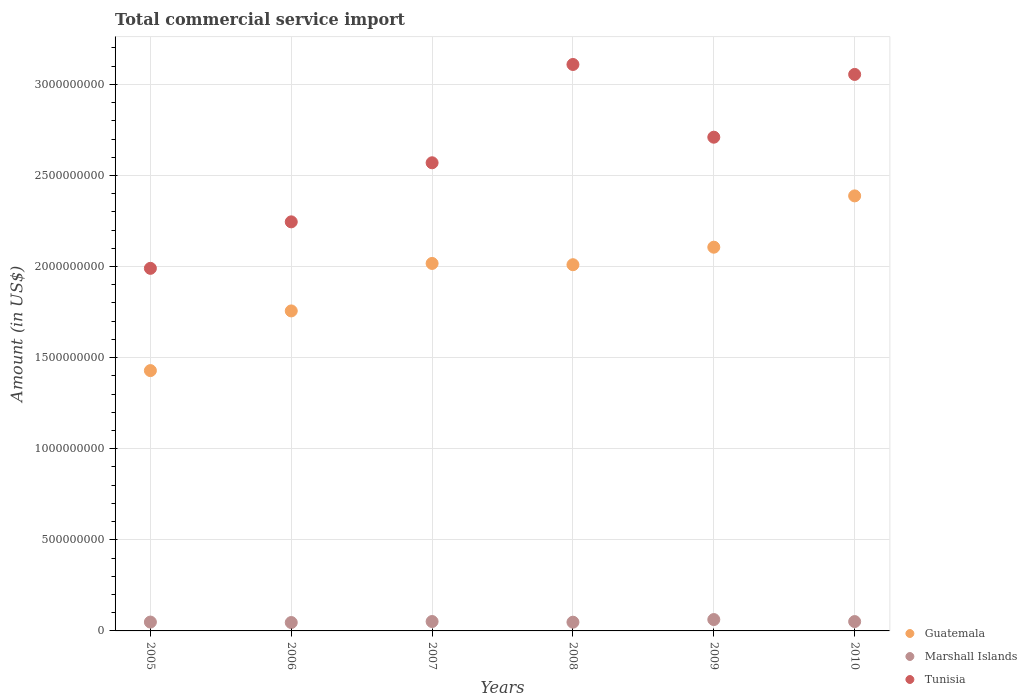How many different coloured dotlines are there?
Your answer should be very brief. 3. Is the number of dotlines equal to the number of legend labels?
Keep it short and to the point. Yes. What is the total commercial service import in Guatemala in 2009?
Your answer should be very brief. 2.11e+09. Across all years, what is the maximum total commercial service import in Tunisia?
Offer a terse response. 3.11e+09. Across all years, what is the minimum total commercial service import in Marshall Islands?
Your answer should be very brief. 4.60e+07. In which year was the total commercial service import in Marshall Islands maximum?
Your answer should be compact. 2009. What is the total total commercial service import in Marshall Islands in the graph?
Provide a short and direct response. 3.08e+08. What is the difference between the total commercial service import in Guatemala in 2006 and that in 2008?
Make the answer very short. -2.54e+08. What is the difference between the total commercial service import in Marshall Islands in 2007 and the total commercial service import in Tunisia in 2010?
Your answer should be very brief. -3.00e+09. What is the average total commercial service import in Marshall Islands per year?
Keep it short and to the point. 5.13e+07. In the year 2007, what is the difference between the total commercial service import in Guatemala and total commercial service import in Tunisia?
Your answer should be very brief. -5.53e+08. What is the ratio of the total commercial service import in Marshall Islands in 2006 to that in 2010?
Provide a short and direct response. 0.9. Is the total commercial service import in Tunisia in 2005 less than that in 2008?
Give a very brief answer. Yes. Is the difference between the total commercial service import in Guatemala in 2005 and 2010 greater than the difference between the total commercial service import in Tunisia in 2005 and 2010?
Offer a very short reply. Yes. What is the difference between the highest and the second highest total commercial service import in Marshall Islands?
Ensure brevity in your answer.  1.08e+07. What is the difference between the highest and the lowest total commercial service import in Guatemala?
Make the answer very short. 9.59e+08. In how many years, is the total commercial service import in Guatemala greater than the average total commercial service import in Guatemala taken over all years?
Ensure brevity in your answer.  4. Is the sum of the total commercial service import in Guatemala in 2007 and 2009 greater than the maximum total commercial service import in Marshall Islands across all years?
Provide a succinct answer. Yes. Are the values on the major ticks of Y-axis written in scientific E-notation?
Keep it short and to the point. No. Does the graph contain grids?
Your response must be concise. Yes. Where does the legend appear in the graph?
Make the answer very short. Bottom right. How many legend labels are there?
Your answer should be compact. 3. How are the legend labels stacked?
Your response must be concise. Vertical. What is the title of the graph?
Offer a very short reply. Total commercial service import. What is the label or title of the X-axis?
Your response must be concise. Years. What is the label or title of the Y-axis?
Ensure brevity in your answer.  Amount (in US$). What is the Amount (in US$) in Guatemala in 2005?
Ensure brevity in your answer.  1.43e+09. What is the Amount (in US$) of Marshall Islands in 2005?
Your answer should be compact. 4.86e+07. What is the Amount (in US$) in Tunisia in 2005?
Keep it short and to the point. 1.99e+09. What is the Amount (in US$) in Guatemala in 2006?
Offer a terse response. 1.76e+09. What is the Amount (in US$) of Marshall Islands in 2006?
Ensure brevity in your answer.  4.60e+07. What is the Amount (in US$) in Tunisia in 2006?
Your answer should be very brief. 2.25e+09. What is the Amount (in US$) of Guatemala in 2007?
Ensure brevity in your answer.  2.02e+09. What is the Amount (in US$) in Marshall Islands in 2007?
Ensure brevity in your answer.  5.16e+07. What is the Amount (in US$) in Tunisia in 2007?
Make the answer very short. 2.57e+09. What is the Amount (in US$) of Guatemala in 2008?
Your response must be concise. 2.01e+09. What is the Amount (in US$) of Marshall Islands in 2008?
Ensure brevity in your answer.  4.79e+07. What is the Amount (in US$) of Tunisia in 2008?
Provide a succinct answer. 3.11e+09. What is the Amount (in US$) of Guatemala in 2009?
Ensure brevity in your answer.  2.11e+09. What is the Amount (in US$) in Marshall Islands in 2009?
Provide a succinct answer. 6.24e+07. What is the Amount (in US$) in Tunisia in 2009?
Offer a very short reply. 2.71e+09. What is the Amount (in US$) of Guatemala in 2010?
Your answer should be compact. 2.39e+09. What is the Amount (in US$) of Marshall Islands in 2010?
Provide a succinct answer. 5.13e+07. What is the Amount (in US$) in Tunisia in 2010?
Provide a short and direct response. 3.05e+09. Across all years, what is the maximum Amount (in US$) of Guatemala?
Your answer should be compact. 2.39e+09. Across all years, what is the maximum Amount (in US$) of Marshall Islands?
Ensure brevity in your answer.  6.24e+07. Across all years, what is the maximum Amount (in US$) in Tunisia?
Give a very brief answer. 3.11e+09. Across all years, what is the minimum Amount (in US$) of Guatemala?
Make the answer very short. 1.43e+09. Across all years, what is the minimum Amount (in US$) of Marshall Islands?
Keep it short and to the point. 4.60e+07. Across all years, what is the minimum Amount (in US$) of Tunisia?
Offer a terse response. 1.99e+09. What is the total Amount (in US$) of Guatemala in the graph?
Provide a short and direct response. 1.17e+1. What is the total Amount (in US$) in Marshall Islands in the graph?
Ensure brevity in your answer.  3.08e+08. What is the total Amount (in US$) in Tunisia in the graph?
Offer a terse response. 1.57e+1. What is the difference between the Amount (in US$) in Guatemala in 2005 and that in 2006?
Your answer should be very brief. -3.28e+08. What is the difference between the Amount (in US$) of Marshall Islands in 2005 and that in 2006?
Provide a succinct answer. 2.52e+06. What is the difference between the Amount (in US$) in Tunisia in 2005 and that in 2006?
Make the answer very short. -2.55e+08. What is the difference between the Amount (in US$) of Guatemala in 2005 and that in 2007?
Keep it short and to the point. -5.88e+08. What is the difference between the Amount (in US$) of Marshall Islands in 2005 and that in 2007?
Offer a terse response. -3.00e+06. What is the difference between the Amount (in US$) of Tunisia in 2005 and that in 2007?
Your response must be concise. -5.79e+08. What is the difference between the Amount (in US$) in Guatemala in 2005 and that in 2008?
Make the answer very short. -5.81e+08. What is the difference between the Amount (in US$) of Marshall Islands in 2005 and that in 2008?
Offer a terse response. 6.47e+05. What is the difference between the Amount (in US$) in Tunisia in 2005 and that in 2008?
Your response must be concise. -1.12e+09. What is the difference between the Amount (in US$) in Guatemala in 2005 and that in 2009?
Keep it short and to the point. -6.77e+08. What is the difference between the Amount (in US$) in Marshall Islands in 2005 and that in 2009?
Make the answer very short. -1.38e+07. What is the difference between the Amount (in US$) in Tunisia in 2005 and that in 2009?
Ensure brevity in your answer.  -7.20e+08. What is the difference between the Amount (in US$) of Guatemala in 2005 and that in 2010?
Make the answer very short. -9.59e+08. What is the difference between the Amount (in US$) in Marshall Islands in 2005 and that in 2010?
Ensure brevity in your answer.  -2.75e+06. What is the difference between the Amount (in US$) of Tunisia in 2005 and that in 2010?
Ensure brevity in your answer.  -1.06e+09. What is the difference between the Amount (in US$) in Guatemala in 2006 and that in 2007?
Your answer should be very brief. -2.61e+08. What is the difference between the Amount (in US$) in Marshall Islands in 2006 and that in 2007?
Give a very brief answer. -5.52e+06. What is the difference between the Amount (in US$) in Tunisia in 2006 and that in 2007?
Provide a short and direct response. -3.24e+08. What is the difference between the Amount (in US$) of Guatemala in 2006 and that in 2008?
Offer a very short reply. -2.54e+08. What is the difference between the Amount (in US$) of Marshall Islands in 2006 and that in 2008?
Your answer should be very brief. -1.87e+06. What is the difference between the Amount (in US$) in Tunisia in 2006 and that in 2008?
Offer a terse response. -8.64e+08. What is the difference between the Amount (in US$) in Guatemala in 2006 and that in 2009?
Your response must be concise. -3.50e+08. What is the difference between the Amount (in US$) in Marshall Islands in 2006 and that in 2009?
Make the answer very short. -1.63e+07. What is the difference between the Amount (in US$) of Tunisia in 2006 and that in 2009?
Provide a succinct answer. -4.65e+08. What is the difference between the Amount (in US$) in Guatemala in 2006 and that in 2010?
Provide a succinct answer. -6.31e+08. What is the difference between the Amount (in US$) in Marshall Islands in 2006 and that in 2010?
Your answer should be very brief. -5.27e+06. What is the difference between the Amount (in US$) in Tunisia in 2006 and that in 2010?
Your answer should be compact. -8.09e+08. What is the difference between the Amount (in US$) of Guatemala in 2007 and that in 2008?
Make the answer very short. 6.97e+06. What is the difference between the Amount (in US$) in Marshall Islands in 2007 and that in 2008?
Give a very brief answer. 3.65e+06. What is the difference between the Amount (in US$) in Tunisia in 2007 and that in 2008?
Your answer should be compact. -5.40e+08. What is the difference between the Amount (in US$) of Guatemala in 2007 and that in 2009?
Your answer should be compact. -8.92e+07. What is the difference between the Amount (in US$) in Marshall Islands in 2007 and that in 2009?
Offer a terse response. -1.08e+07. What is the difference between the Amount (in US$) of Tunisia in 2007 and that in 2009?
Provide a succinct answer. -1.40e+08. What is the difference between the Amount (in US$) of Guatemala in 2007 and that in 2010?
Provide a succinct answer. -3.71e+08. What is the difference between the Amount (in US$) of Marshall Islands in 2007 and that in 2010?
Keep it short and to the point. 2.51e+05. What is the difference between the Amount (in US$) of Tunisia in 2007 and that in 2010?
Give a very brief answer. -4.85e+08. What is the difference between the Amount (in US$) of Guatemala in 2008 and that in 2009?
Offer a very short reply. -9.61e+07. What is the difference between the Amount (in US$) of Marshall Islands in 2008 and that in 2009?
Offer a very short reply. -1.45e+07. What is the difference between the Amount (in US$) in Tunisia in 2008 and that in 2009?
Your response must be concise. 3.99e+08. What is the difference between the Amount (in US$) of Guatemala in 2008 and that in 2010?
Give a very brief answer. -3.78e+08. What is the difference between the Amount (in US$) of Marshall Islands in 2008 and that in 2010?
Provide a short and direct response. -3.40e+06. What is the difference between the Amount (in US$) in Tunisia in 2008 and that in 2010?
Provide a succinct answer. 5.46e+07. What is the difference between the Amount (in US$) in Guatemala in 2009 and that in 2010?
Your answer should be compact. -2.82e+08. What is the difference between the Amount (in US$) in Marshall Islands in 2009 and that in 2010?
Provide a succinct answer. 1.11e+07. What is the difference between the Amount (in US$) of Tunisia in 2009 and that in 2010?
Ensure brevity in your answer.  -3.45e+08. What is the difference between the Amount (in US$) in Guatemala in 2005 and the Amount (in US$) in Marshall Islands in 2006?
Provide a short and direct response. 1.38e+09. What is the difference between the Amount (in US$) of Guatemala in 2005 and the Amount (in US$) of Tunisia in 2006?
Provide a succinct answer. -8.16e+08. What is the difference between the Amount (in US$) of Marshall Islands in 2005 and the Amount (in US$) of Tunisia in 2006?
Provide a short and direct response. -2.20e+09. What is the difference between the Amount (in US$) in Guatemala in 2005 and the Amount (in US$) in Marshall Islands in 2007?
Offer a very short reply. 1.38e+09. What is the difference between the Amount (in US$) in Guatemala in 2005 and the Amount (in US$) in Tunisia in 2007?
Provide a short and direct response. -1.14e+09. What is the difference between the Amount (in US$) in Marshall Islands in 2005 and the Amount (in US$) in Tunisia in 2007?
Your answer should be very brief. -2.52e+09. What is the difference between the Amount (in US$) in Guatemala in 2005 and the Amount (in US$) in Marshall Islands in 2008?
Make the answer very short. 1.38e+09. What is the difference between the Amount (in US$) of Guatemala in 2005 and the Amount (in US$) of Tunisia in 2008?
Your answer should be compact. -1.68e+09. What is the difference between the Amount (in US$) of Marshall Islands in 2005 and the Amount (in US$) of Tunisia in 2008?
Offer a terse response. -3.06e+09. What is the difference between the Amount (in US$) of Guatemala in 2005 and the Amount (in US$) of Marshall Islands in 2009?
Offer a terse response. 1.37e+09. What is the difference between the Amount (in US$) in Guatemala in 2005 and the Amount (in US$) in Tunisia in 2009?
Provide a succinct answer. -1.28e+09. What is the difference between the Amount (in US$) in Marshall Islands in 2005 and the Amount (in US$) in Tunisia in 2009?
Provide a succinct answer. -2.66e+09. What is the difference between the Amount (in US$) in Guatemala in 2005 and the Amount (in US$) in Marshall Islands in 2010?
Offer a terse response. 1.38e+09. What is the difference between the Amount (in US$) in Guatemala in 2005 and the Amount (in US$) in Tunisia in 2010?
Give a very brief answer. -1.63e+09. What is the difference between the Amount (in US$) in Marshall Islands in 2005 and the Amount (in US$) in Tunisia in 2010?
Your answer should be compact. -3.01e+09. What is the difference between the Amount (in US$) of Guatemala in 2006 and the Amount (in US$) of Marshall Islands in 2007?
Ensure brevity in your answer.  1.70e+09. What is the difference between the Amount (in US$) in Guatemala in 2006 and the Amount (in US$) in Tunisia in 2007?
Offer a very short reply. -8.13e+08. What is the difference between the Amount (in US$) in Marshall Islands in 2006 and the Amount (in US$) in Tunisia in 2007?
Provide a succinct answer. -2.52e+09. What is the difference between the Amount (in US$) of Guatemala in 2006 and the Amount (in US$) of Marshall Islands in 2008?
Provide a short and direct response. 1.71e+09. What is the difference between the Amount (in US$) in Guatemala in 2006 and the Amount (in US$) in Tunisia in 2008?
Your response must be concise. -1.35e+09. What is the difference between the Amount (in US$) of Marshall Islands in 2006 and the Amount (in US$) of Tunisia in 2008?
Offer a terse response. -3.06e+09. What is the difference between the Amount (in US$) of Guatemala in 2006 and the Amount (in US$) of Marshall Islands in 2009?
Your answer should be compact. 1.69e+09. What is the difference between the Amount (in US$) in Guatemala in 2006 and the Amount (in US$) in Tunisia in 2009?
Provide a succinct answer. -9.53e+08. What is the difference between the Amount (in US$) in Marshall Islands in 2006 and the Amount (in US$) in Tunisia in 2009?
Your response must be concise. -2.66e+09. What is the difference between the Amount (in US$) of Guatemala in 2006 and the Amount (in US$) of Marshall Islands in 2010?
Offer a terse response. 1.71e+09. What is the difference between the Amount (in US$) of Guatemala in 2006 and the Amount (in US$) of Tunisia in 2010?
Give a very brief answer. -1.30e+09. What is the difference between the Amount (in US$) in Marshall Islands in 2006 and the Amount (in US$) in Tunisia in 2010?
Make the answer very short. -3.01e+09. What is the difference between the Amount (in US$) of Guatemala in 2007 and the Amount (in US$) of Marshall Islands in 2008?
Your response must be concise. 1.97e+09. What is the difference between the Amount (in US$) of Guatemala in 2007 and the Amount (in US$) of Tunisia in 2008?
Your answer should be compact. -1.09e+09. What is the difference between the Amount (in US$) of Marshall Islands in 2007 and the Amount (in US$) of Tunisia in 2008?
Ensure brevity in your answer.  -3.06e+09. What is the difference between the Amount (in US$) of Guatemala in 2007 and the Amount (in US$) of Marshall Islands in 2009?
Keep it short and to the point. 1.95e+09. What is the difference between the Amount (in US$) in Guatemala in 2007 and the Amount (in US$) in Tunisia in 2009?
Provide a succinct answer. -6.93e+08. What is the difference between the Amount (in US$) of Marshall Islands in 2007 and the Amount (in US$) of Tunisia in 2009?
Your answer should be very brief. -2.66e+09. What is the difference between the Amount (in US$) of Guatemala in 2007 and the Amount (in US$) of Marshall Islands in 2010?
Ensure brevity in your answer.  1.97e+09. What is the difference between the Amount (in US$) in Guatemala in 2007 and the Amount (in US$) in Tunisia in 2010?
Make the answer very short. -1.04e+09. What is the difference between the Amount (in US$) in Marshall Islands in 2007 and the Amount (in US$) in Tunisia in 2010?
Your answer should be compact. -3.00e+09. What is the difference between the Amount (in US$) of Guatemala in 2008 and the Amount (in US$) of Marshall Islands in 2009?
Make the answer very short. 1.95e+09. What is the difference between the Amount (in US$) of Guatemala in 2008 and the Amount (in US$) of Tunisia in 2009?
Provide a short and direct response. -7.00e+08. What is the difference between the Amount (in US$) of Marshall Islands in 2008 and the Amount (in US$) of Tunisia in 2009?
Ensure brevity in your answer.  -2.66e+09. What is the difference between the Amount (in US$) in Guatemala in 2008 and the Amount (in US$) in Marshall Islands in 2010?
Ensure brevity in your answer.  1.96e+09. What is the difference between the Amount (in US$) of Guatemala in 2008 and the Amount (in US$) of Tunisia in 2010?
Your answer should be very brief. -1.04e+09. What is the difference between the Amount (in US$) of Marshall Islands in 2008 and the Amount (in US$) of Tunisia in 2010?
Your answer should be compact. -3.01e+09. What is the difference between the Amount (in US$) in Guatemala in 2009 and the Amount (in US$) in Marshall Islands in 2010?
Give a very brief answer. 2.05e+09. What is the difference between the Amount (in US$) of Guatemala in 2009 and the Amount (in US$) of Tunisia in 2010?
Provide a succinct answer. -9.48e+08. What is the difference between the Amount (in US$) in Marshall Islands in 2009 and the Amount (in US$) in Tunisia in 2010?
Offer a very short reply. -2.99e+09. What is the average Amount (in US$) in Guatemala per year?
Make the answer very short. 1.95e+09. What is the average Amount (in US$) in Marshall Islands per year?
Keep it short and to the point. 5.13e+07. What is the average Amount (in US$) in Tunisia per year?
Provide a short and direct response. 2.61e+09. In the year 2005, what is the difference between the Amount (in US$) in Guatemala and Amount (in US$) in Marshall Islands?
Your answer should be compact. 1.38e+09. In the year 2005, what is the difference between the Amount (in US$) of Guatemala and Amount (in US$) of Tunisia?
Offer a very short reply. -5.61e+08. In the year 2005, what is the difference between the Amount (in US$) in Marshall Islands and Amount (in US$) in Tunisia?
Give a very brief answer. -1.94e+09. In the year 2006, what is the difference between the Amount (in US$) of Guatemala and Amount (in US$) of Marshall Islands?
Your answer should be compact. 1.71e+09. In the year 2006, what is the difference between the Amount (in US$) of Guatemala and Amount (in US$) of Tunisia?
Offer a very short reply. -4.89e+08. In the year 2006, what is the difference between the Amount (in US$) in Marshall Islands and Amount (in US$) in Tunisia?
Provide a succinct answer. -2.20e+09. In the year 2007, what is the difference between the Amount (in US$) in Guatemala and Amount (in US$) in Marshall Islands?
Provide a succinct answer. 1.97e+09. In the year 2007, what is the difference between the Amount (in US$) in Guatemala and Amount (in US$) in Tunisia?
Provide a short and direct response. -5.53e+08. In the year 2007, what is the difference between the Amount (in US$) of Marshall Islands and Amount (in US$) of Tunisia?
Keep it short and to the point. -2.52e+09. In the year 2008, what is the difference between the Amount (in US$) of Guatemala and Amount (in US$) of Marshall Islands?
Provide a succinct answer. 1.96e+09. In the year 2008, what is the difference between the Amount (in US$) in Guatemala and Amount (in US$) in Tunisia?
Your answer should be compact. -1.10e+09. In the year 2008, what is the difference between the Amount (in US$) of Marshall Islands and Amount (in US$) of Tunisia?
Your response must be concise. -3.06e+09. In the year 2009, what is the difference between the Amount (in US$) of Guatemala and Amount (in US$) of Marshall Islands?
Ensure brevity in your answer.  2.04e+09. In the year 2009, what is the difference between the Amount (in US$) of Guatemala and Amount (in US$) of Tunisia?
Your answer should be compact. -6.04e+08. In the year 2009, what is the difference between the Amount (in US$) in Marshall Islands and Amount (in US$) in Tunisia?
Provide a short and direct response. -2.65e+09. In the year 2010, what is the difference between the Amount (in US$) of Guatemala and Amount (in US$) of Marshall Islands?
Give a very brief answer. 2.34e+09. In the year 2010, what is the difference between the Amount (in US$) of Guatemala and Amount (in US$) of Tunisia?
Provide a short and direct response. -6.67e+08. In the year 2010, what is the difference between the Amount (in US$) in Marshall Islands and Amount (in US$) in Tunisia?
Your response must be concise. -3.00e+09. What is the ratio of the Amount (in US$) in Guatemala in 2005 to that in 2006?
Offer a very short reply. 0.81. What is the ratio of the Amount (in US$) in Marshall Islands in 2005 to that in 2006?
Ensure brevity in your answer.  1.05. What is the ratio of the Amount (in US$) in Tunisia in 2005 to that in 2006?
Make the answer very short. 0.89. What is the ratio of the Amount (in US$) in Guatemala in 2005 to that in 2007?
Your answer should be very brief. 0.71. What is the ratio of the Amount (in US$) in Marshall Islands in 2005 to that in 2007?
Your answer should be very brief. 0.94. What is the ratio of the Amount (in US$) of Tunisia in 2005 to that in 2007?
Make the answer very short. 0.77. What is the ratio of the Amount (in US$) in Guatemala in 2005 to that in 2008?
Provide a succinct answer. 0.71. What is the ratio of the Amount (in US$) of Marshall Islands in 2005 to that in 2008?
Provide a short and direct response. 1.01. What is the ratio of the Amount (in US$) of Tunisia in 2005 to that in 2008?
Your answer should be compact. 0.64. What is the ratio of the Amount (in US$) of Guatemala in 2005 to that in 2009?
Offer a very short reply. 0.68. What is the ratio of the Amount (in US$) in Marshall Islands in 2005 to that in 2009?
Your answer should be compact. 0.78. What is the ratio of the Amount (in US$) of Tunisia in 2005 to that in 2009?
Give a very brief answer. 0.73. What is the ratio of the Amount (in US$) of Guatemala in 2005 to that in 2010?
Provide a short and direct response. 0.6. What is the ratio of the Amount (in US$) in Marshall Islands in 2005 to that in 2010?
Provide a succinct answer. 0.95. What is the ratio of the Amount (in US$) of Tunisia in 2005 to that in 2010?
Make the answer very short. 0.65. What is the ratio of the Amount (in US$) in Guatemala in 2006 to that in 2007?
Offer a terse response. 0.87. What is the ratio of the Amount (in US$) of Marshall Islands in 2006 to that in 2007?
Your response must be concise. 0.89. What is the ratio of the Amount (in US$) of Tunisia in 2006 to that in 2007?
Your response must be concise. 0.87. What is the ratio of the Amount (in US$) in Guatemala in 2006 to that in 2008?
Provide a short and direct response. 0.87. What is the ratio of the Amount (in US$) of Marshall Islands in 2006 to that in 2008?
Your answer should be compact. 0.96. What is the ratio of the Amount (in US$) in Tunisia in 2006 to that in 2008?
Ensure brevity in your answer.  0.72. What is the ratio of the Amount (in US$) of Guatemala in 2006 to that in 2009?
Offer a terse response. 0.83. What is the ratio of the Amount (in US$) of Marshall Islands in 2006 to that in 2009?
Your answer should be compact. 0.74. What is the ratio of the Amount (in US$) of Tunisia in 2006 to that in 2009?
Give a very brief answer. 0.83. What is the ratio of the Amount (in US$) of Guatemala in 2006 to that in 2010?
Ensure brevity in your answer.  0.74. What is the ratio of the Amount (in US$) in Marshall Islands in 2006 to that in 2010?
Offer a very short reply. 0.9. What is the ratio of the Amount (in US$) in Tunisia in 2006 to that in 2010?
Provide a succinct answer. 0.74. What is the ratio of the Amount (in US$) in Marshall Islands in 2007 to that in 2008?
Your answer should be very brief. 1.08. What is the ratio of the Amount (in US$) of Tunisia in 2007 to that in 2008?
Your answer should be compact. 0.83. What is the ratio of the Amount (in US$) of Guatemala in 2007 to that in 2009?
Your answer should be compact. 0.96. What is the ratio of the Amount (in US$) in Marshall Islands in 2007 to that in 2009?
Your response must be concise. 0.83. What is the ratio of the Amount (in US$) in Tunisia in 2007 to that in 2009?
Make the answer very short. 0.95. What is the ratio of the Amount (in US$) in Guatemala in 2007 to that in 2010?
Your answer should be compact. 0.84. What is the ratio of the Amount (in US$) in Tunisia in 2007 to that in 2010?
Your answer should be very brief. 0.84. What is the ratio of the Amount (in US$) of Guatemala in 2008 to that in 2009?
Ensure brevity in your answer.  0.95. What is the ratio of the Amount (in US$) in Marshall Islands in 2008 to that in 2009?
Provide a succinct answer. 0.77. What is the ratio of the Amount (in US$) of Tunisia in 2008 to that in 2009?
Your answer should be compact. 1.15. What is the ratio of the Amount (in US$) in Guatemala in 2008 to that in 2010?
Offer a very short reply. 0.84. What is the ratio of the Amount (in US$) in Marshall Islands in 2008 to that in 2010?
Provide a succinct answer. 0.93. What is the ratio of the Amount (in US$) in Tunisia in 2008 to that in 2010?
Keep it short and to the point. 1.02. What is the ratio of the Amount (in US$) in Guatemala in 2009 to that in 2010?
Make the answer very short. 0.88. What is the ratio of the Amount (in US$) in Marshall Islands in 2009 to that in 2010?
Your response must be concise. 1.22. What is the ratio of the Amount (in US$) of Tunisia in 2009 to that in 2010?
Offer a terse response. 0.89. What is the difference between the highest and the second highest Amount (in US$) in Guatemala?
Keep it short and to the point. 2.82e+08. What is the difference between the highest and the second highest Amount (in US$) in Marshall Islands?
Your answer should be very brief. 1.08e+07. What is the difference between the highest and the second highest Amount (in US$) of Tunisia?
Provide a succinct answer. 5.46e+07. What is the difference between the highest and the lowest Amount (in US$) of Guatemala?
Your answer should be compact. 9.59e+08. What is the difference between the highest and the lowest Amount (in US$) in Marshall Islands?
Give a very brief answer. 1.63e+07. What is the difference between the highest and the lowest Amount (in US$) in Tunisia?
Offer a terse response. 1.12e+09. 